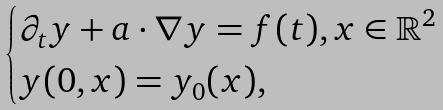<formula> <loc_0><loc_0><loc_500><loc_500>\begin{cases} \partial _ { t } y + a \cdot \nabla y = f ( t ) , x \in \mathbb { R } ^ { 2 } \\ y ( 0 , x ) = y _ { 0 } ( x ) , \end{cases}</formula> 